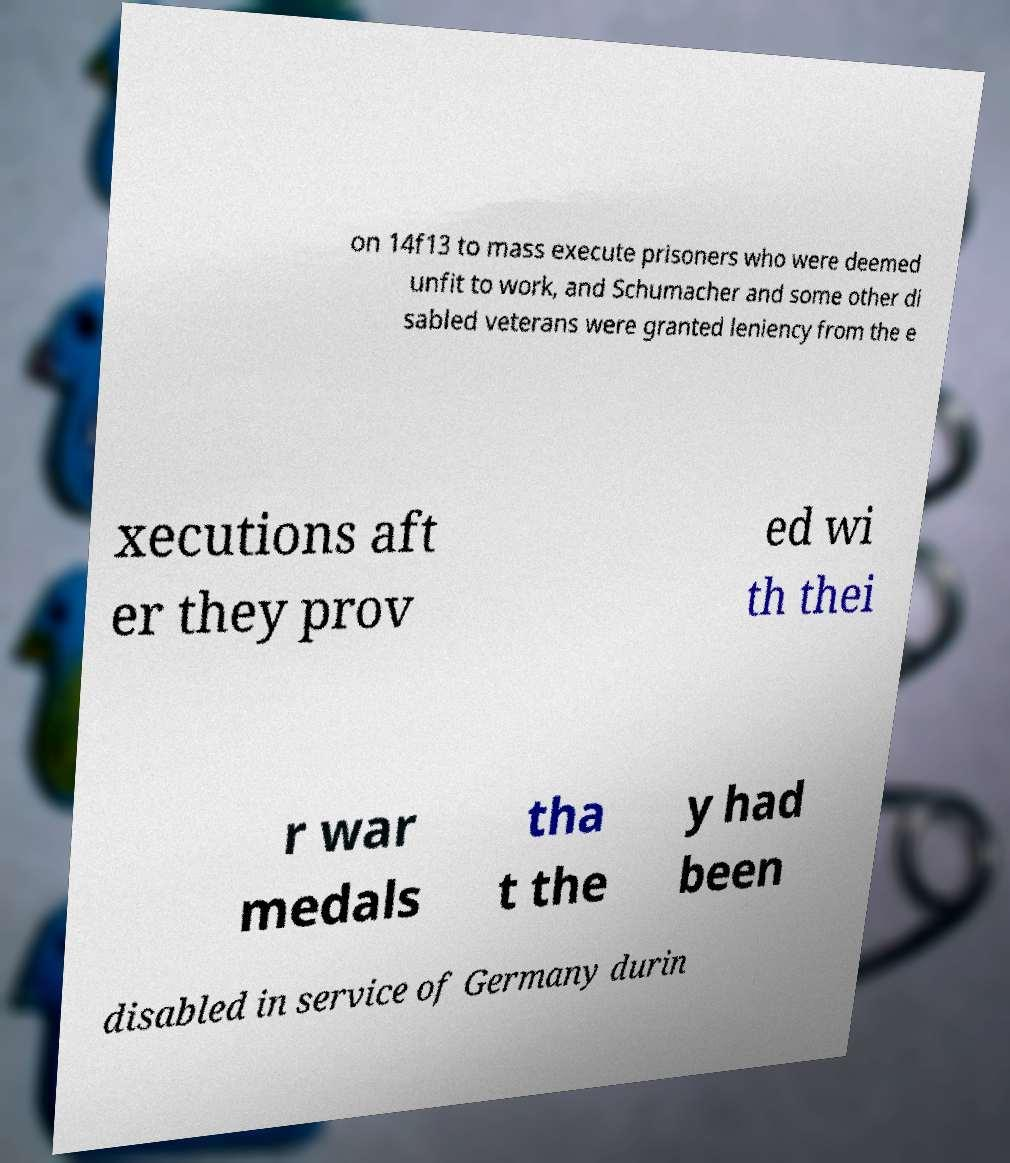Can you accurately transcribe the text from the provided image for me? on 14f13 to mass execute prisoners who were deemed unfit to work, and Schumacher and some other di sabled veterans were granted leniency from the e xecutions aft er they prov ed wi th thei r war medals tha t the y had been disabled in service of Germany durin 